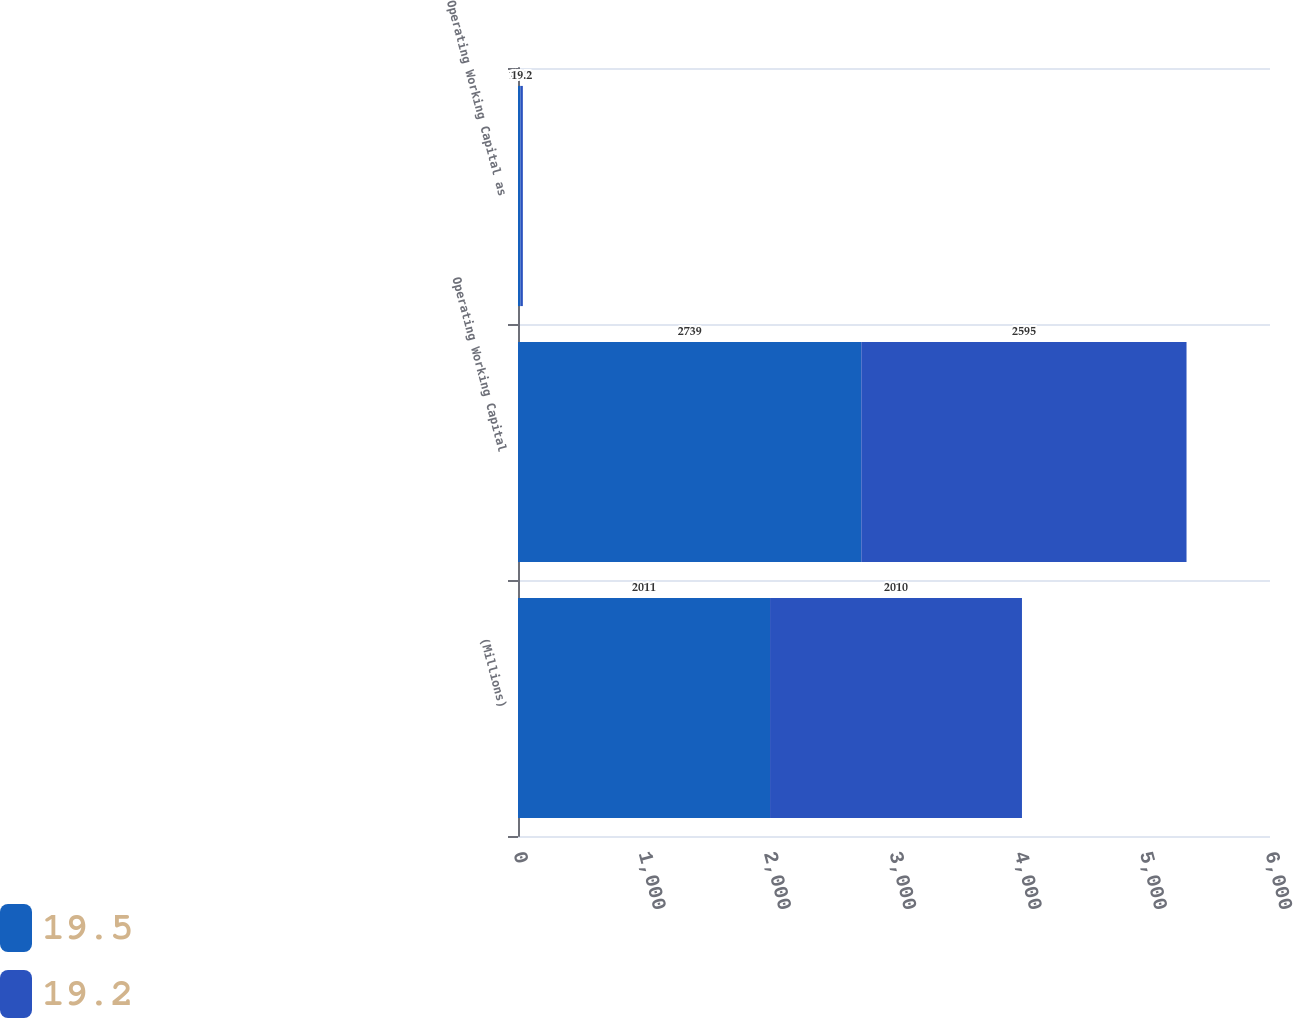Convert chart to OTSL. <chart><loc_0><loc_0><loc_500><loc_500><stacked_bar_chart><ecel><fcel>(Millions)<fcel>Operating Working Capital<fcel>Operating Working Capital as<nl><fcel>19.5<fcel>2011<fcel>2739<fcel>19.5<nl><fcel>19.2<fcel>2010<fcel>2595<fcel>19.2<nl></chart> 